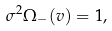<formula> <loc_0><loc_0><loc_500><loc_500>\sigma ^ { 2 } \Omega _ { - } ( v ) = 1 ,</formula> 